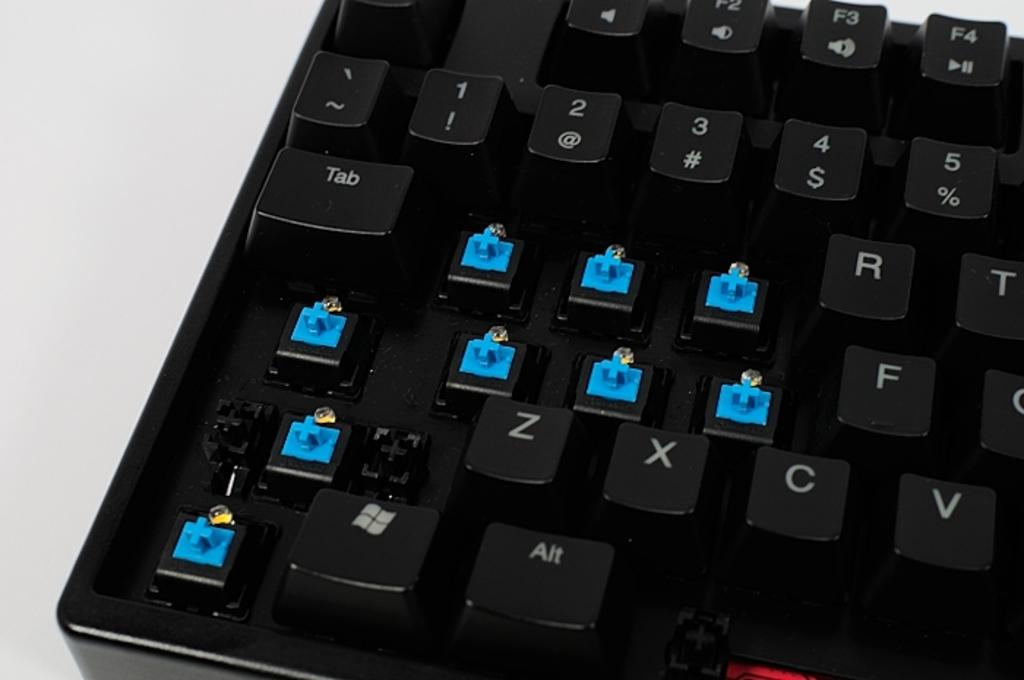What is the main object in the image? There is a keyboard in the image. What is the keyboard placed on? The keyboard is on a white surface. Where is the cemetery located in the image? There is no cemetery present in the image; it only features a keyboard on a white surface. What type of vessel is being used to hold the keyboard in the image? There is no vessel present in the image; the keyboard is simply placed on a white surface. 